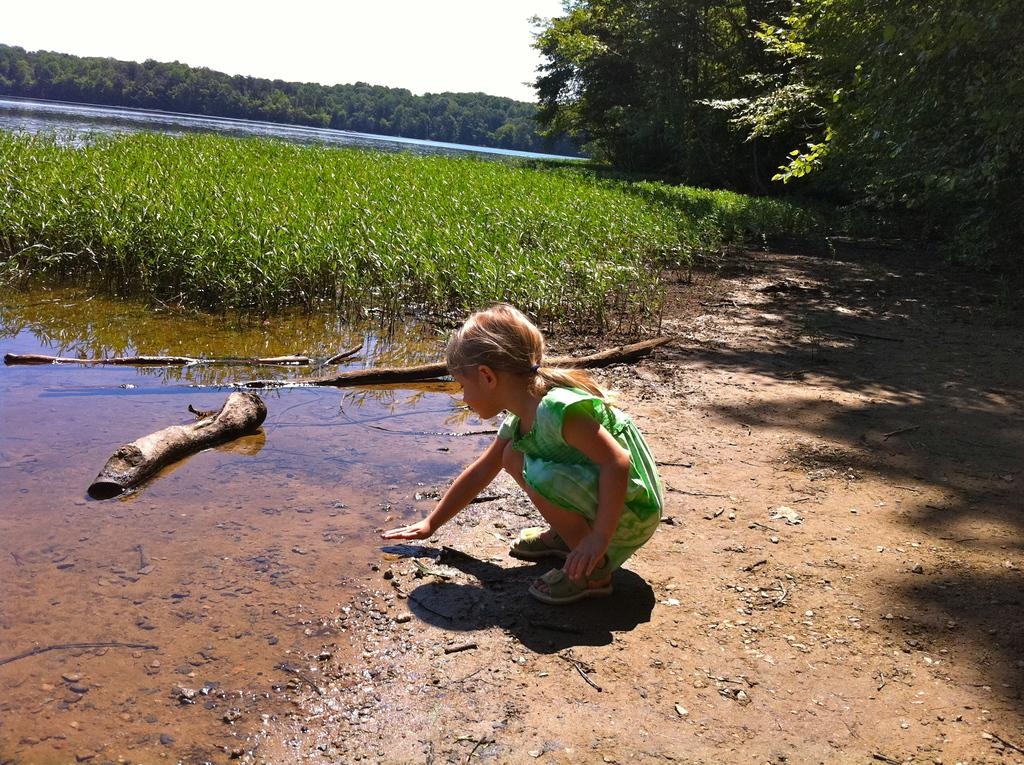Who is the main subject in the image? There is a small girl in the center of the image. What is located on the left side of the image? There is water on the left side of the image. What can be seen at the top side of the image? There are trees at the top side of the image. What type of volleyball is the small girl holding in the image? There is no volleyball present in the image. Can you describe the girl's smile in the image? The provided facts do not mention the girl's smile, so we cannot describe it. 